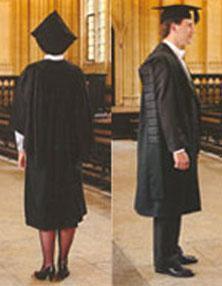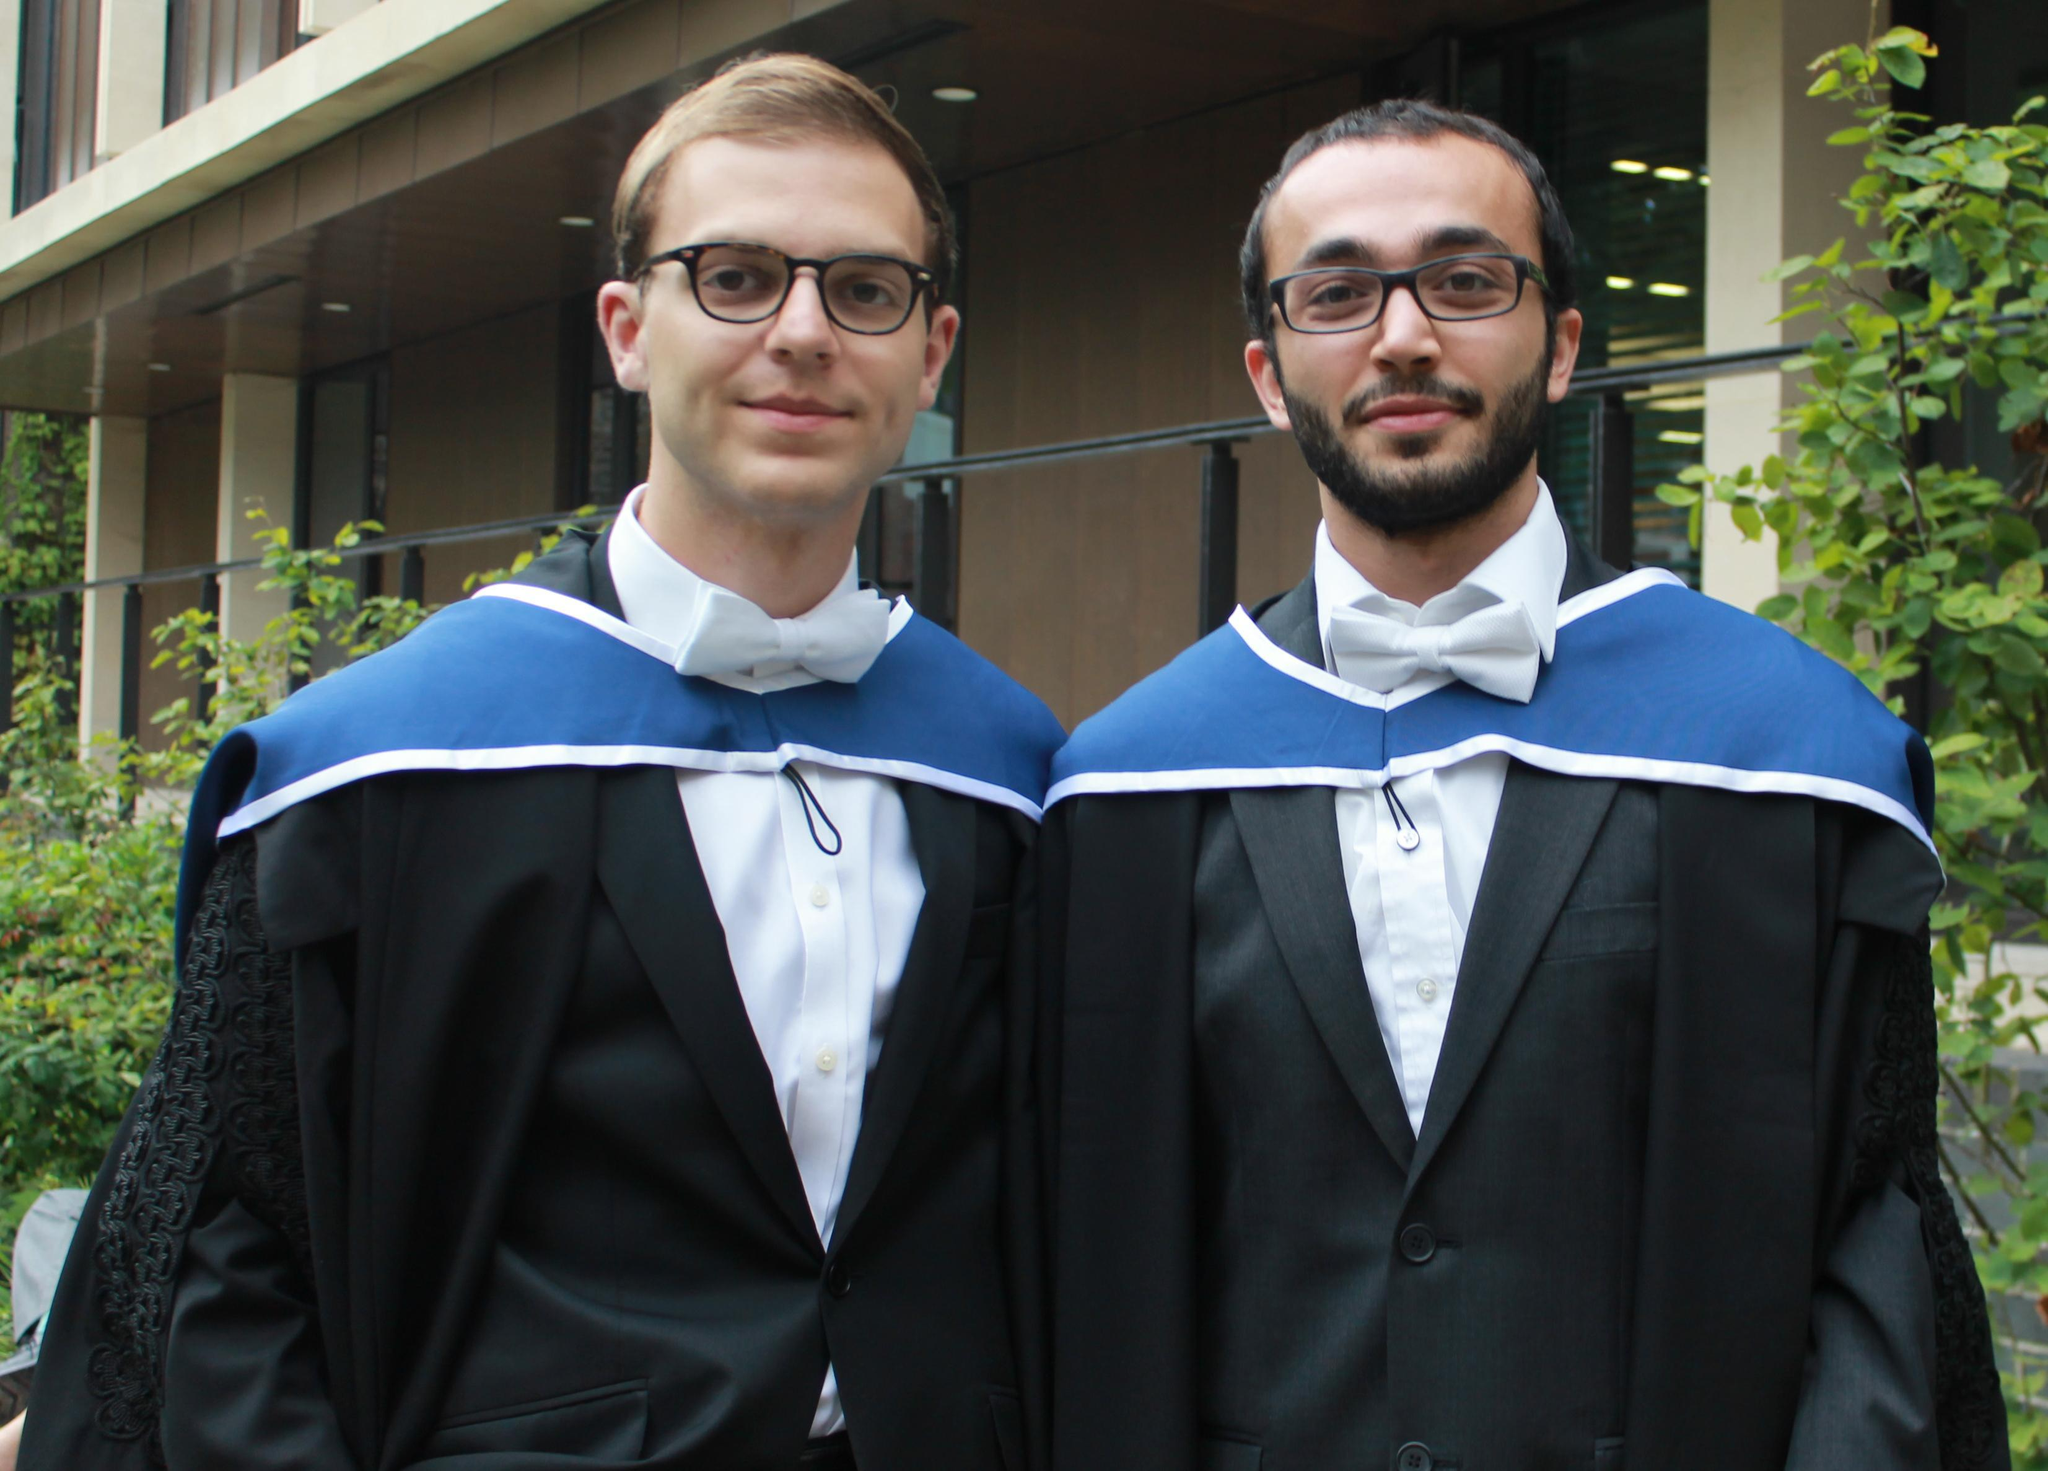The first image is the image on the left, the second image is the image on the right. Examine the images to the left and right. Is the description "An image does not show exactly two people dressed for an occasion." accurate? Answer yes or no. No. 